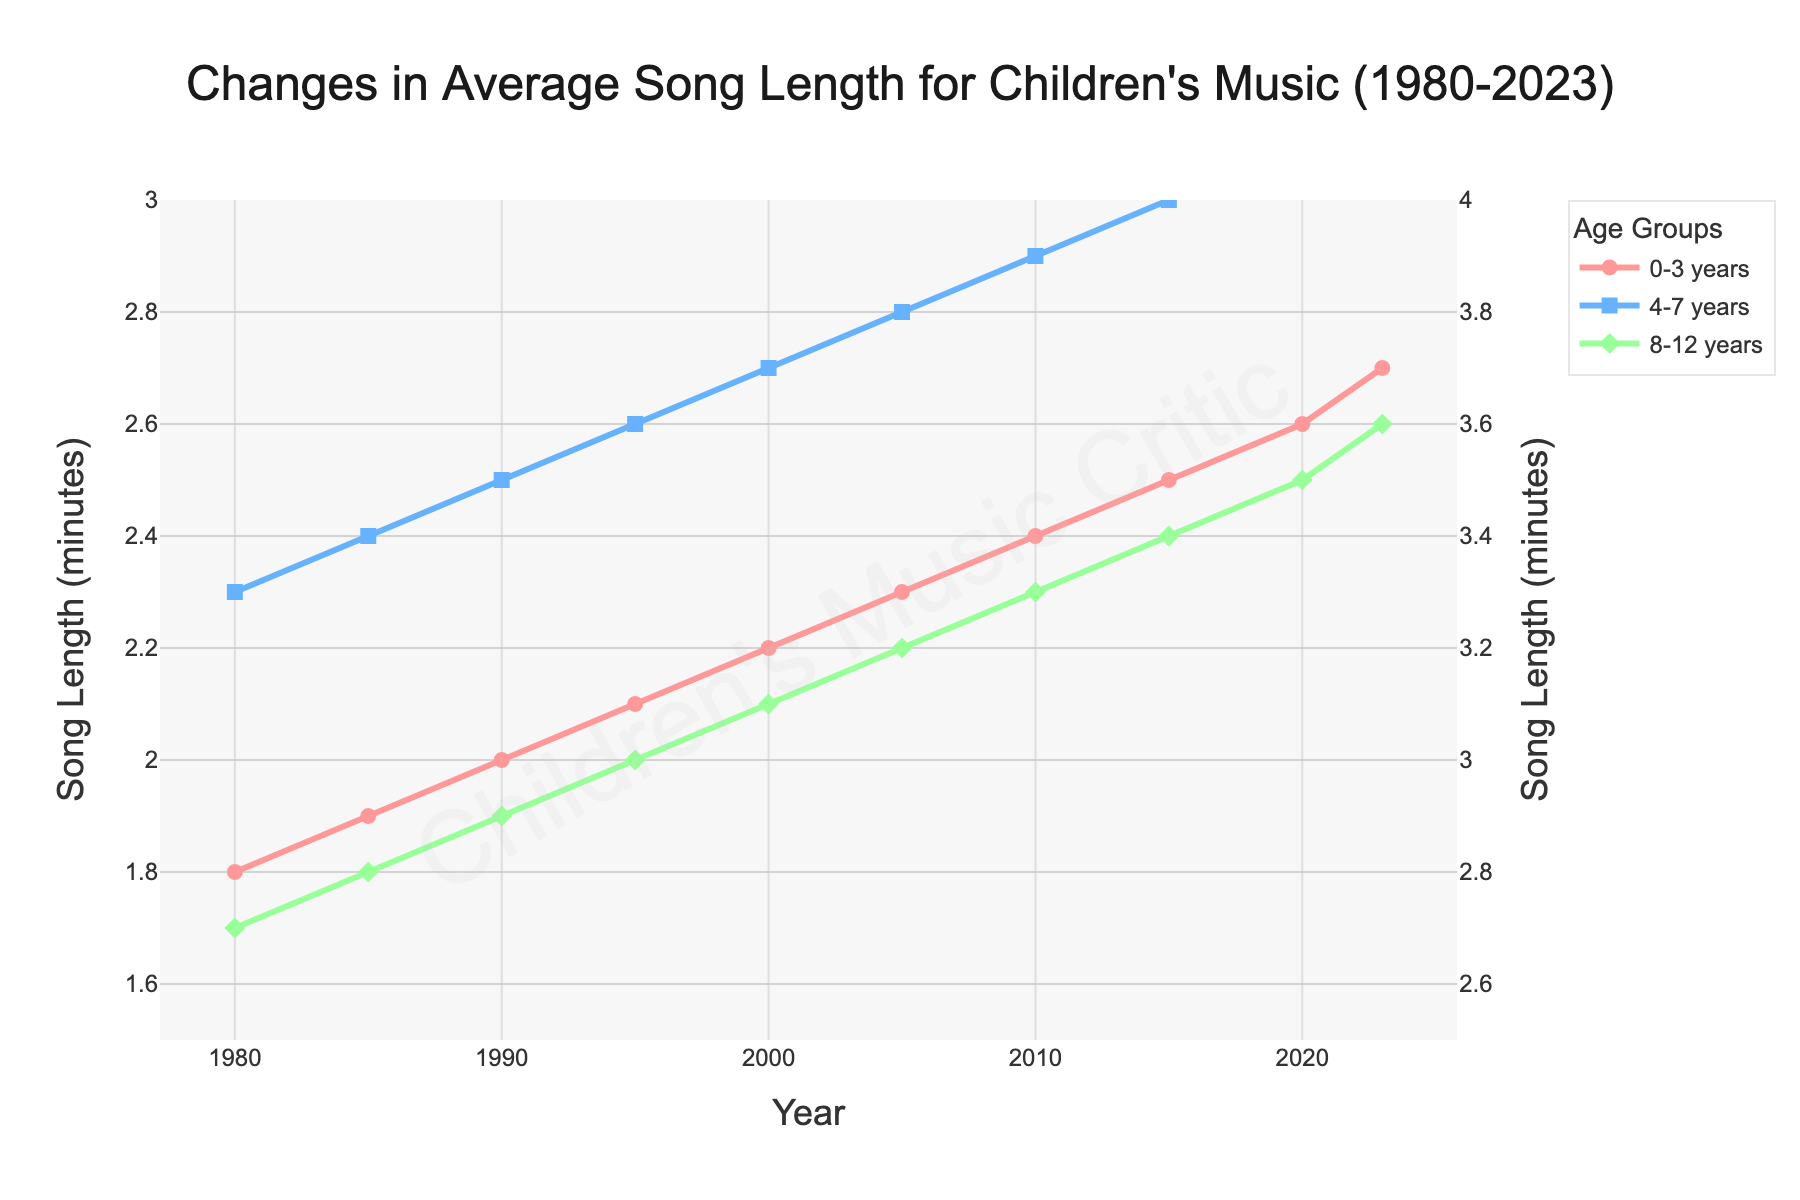What is the difference in song length between the 0-3 years group in 1980 and 2023? To find the difference, subtract the song length in 1980 from the song length in 2023 for the 0-3 years group. This is 2.7 - 1.8.
Answer: 0.9 Which age group saw the greatest increase in average song length from 1980 to 2023? Calculate the difference in song length for each age group from 1980 to 2023. The calculations are: 0-3 years: 2.7 - 1.8 = 0.9, 4-7 years: 3.2 - 2.3 = 0.9, 8-12 years: 3.6 - 2.7 = 0.9. All groups saw the same increase.
Answer: All groups equally In which year did the 8-12 years age group’s song length first reach 3 minutes? Look for the year where the 8-12 years group’s song length is at least 3.0 minutes. This first occurs in 1995.
Answer: 1995 How much longer were the average songs for the 8-12 years group than the 0-3 years group in 2023? Subtract the song length of the 0-3 years group from the 8-12 years group in 2023, which is 3.6 - 2.7.
Answer: 0.9 minutes What is the average song length for the 4-7 years age group over the period 1980 to 2023? Sum all the average song lengths for the 4-7 years group and divide by the number of data points. (2.3 + 2.4 + 2.5 + 2.6 + 2.7 + 2.8 + 2.9 + 3.0 + 3.1 + 3.2) / 10.
Answer: 2.75 minutes Compare the song lengths for the 0-3 and 4-7 years groups in 1990. Which group had longer songs? Check the song lengths for both groups in 1990. 0-3 years: 2.0 minutes, 4-7 years: 2.5 minutes. The 4-7 years group had longer songs.
Answer: 4-7 years group Identify the trend in average song length for the 0-3 years age group from 1980 to 2023. Observe the changes in song lengths over the years for the 0-3 years group. There is a steady increase from 1.8 minutes in 1980 to 2.7 minutes in 2023.
Answer: Increasing During which decade did the 4-7 years group's average song length see the most significant increase? Calculate the differences in song length for each decade for the 4-7 years group: 1980-1990: 2.5 - 2.3 = 0.2, 1990-2000: 2.7 - 2.5 = 0.2, 2000-2010: 2.9 - 2.7 = 0.2, 2010-2020: 3.1 - 2.9 = 0.2. All decades saw the same increase of 0.2.
Answer: All decades equally What were the song lengths for all three age groups in 1985? Refer to the data points for 1985 for each group: 0-3 years: 1.9 minutes, 4-7 years: 2.4 minutes, 8-12 years: 2.8 minutes.
Answer: 1.9 (0-3 years), 2.4 (4-7 years), 2.8 (8-12 years) 